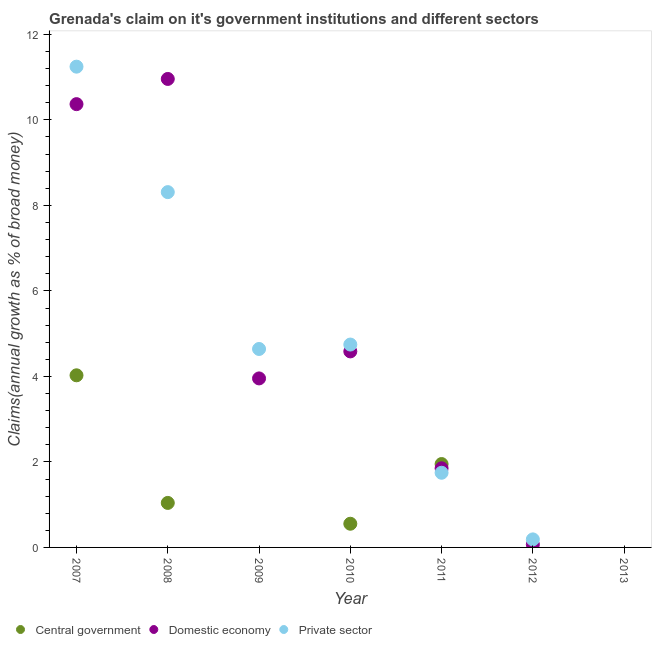What is the percentage of claim on the private sector in 2011?
Your answer should be very brief. 1.75. Across all years, what is the maximum percentage of claim on the private sector?
Give a very brief answer. 11.25. In which year was the percentage of claim on the private sector maximum?
Make the answer very short. 2007. What is the total percentage of claim on the private sector in the graph?
Provide a succinct answer. 30.88. What is the difference between the percentage of claim on the central government in 2010 and that in 2011?
Provide a short and direct response. -1.4. What is the difference between the percentage of claim on the central government in 2013 and the percentage of claim on the private sector in 2009?
Give a very brief answer. -4.64. What is the average percentage of claim on the central government per year?
Give a very brief answer. 1.08. In the year 2008, what is the difference between the percentage of claim on the domestic economy and percentage of claim on the private sector?
Offer a terse response. 2.65. In how many years, is the percentage of claim on the central government greater than 2 %?
Offer a terse response. 1. What is the ratio of the percentage of claim on the domestic economy in 2009 to that in 2011?
Provide a succinct answer. 2.14. What is the difference between the highest and the second highest percentage of claim on the private sector?
Give a very brief answer. 2.93. What is the difference between the highest and the lowest percentage of claim on the domestic economy?
Keep it short and to the point. 10.96. In how many years, is the percentage of claim on the private sector greater than the average percentage of claim on the private sector taken over all years?
Your response must be concise. 4. Is it the case that in every year, the sum of the percentage of claim on the central government and percentage of claim on the domestic economy is greater than the percentage of claim on the private sector?
Your response must be concise. No. Does the percentage of claim on the domestic economy monotonically increase over the years?
Offer a terse response. No. How many dotlines are there?
Give a very brief answer. 3. How many years are there in the graph?
Your answer should be very brief. 7. Are the values on the major ticks of Y-axis written in scientific E-notation?
Give a very brief answer. No. Does the graph contain any zero values?
Offer a terse response. Yes. Does the graph contain grids?
Give a very brief answer. No. How are the legend labels stacked?
Ensure brevity in your answer.  Horizontal. What is the title of the graph?
Give a very brief answer. Grenada's claim on it's government institutions and different sectors. What is the label or title of the Y-axis?
Keep it short and to the point. Claims(annual growth as % of broad money). What is the Claims(annual growth as % of broad money) of Central government in 2007?
Offer a terse response. 4.03. What is the Claims(annual growth as % of broad money) of Domestic economy in 2007?
Give a very brief answer. 10.37. What is the Claims(annual growth as % of broad money) of Private sector in 2007?
Keep it short and to the point. 11.25. What is the Claims(annual growth as % of broad money) of Central government in 2008?
Keep it short and to the point. 1.04. What is the Claims(annual growth as % of broad money) in Domestic economy in 2008?
Keep it short and to the point. 10.96. What is the Claims(annual growth as % of broad money) of Private sector in 2008?
Offer a terse response. 8.31. What is the Claims(annual growth as % of broad money) of Central government in 2009?
Make the answer very short. 0. What is the Claims(annual growth as % of broad money) of Domestic economy in 2009?
Give a very brief answer. 3.95. What is the Claims(annual growth as % of broad money) in Private sector in 2009?
Make the answer very short. 4.64. What is the Claims(annual growth as % of broad money) of Central government in 2010?
Ensure brevity in your answer.  0.55. What is the Claims(annual growth as % of broad money) in Domestic economy in 2010?
Provide a succinct answer. 4.58. What is the Claims(annual growth as % of broad money) of Private sector in 2010?
Offer a very short reply. 4.75. What is the Claims(annual growth as % of broad money) of Central government in 2011?
Offer a terse response. 1.95. What is the Claims(annual growth as % of broad money) of Domestic economy in 2011?
Offer a terse response. 1.85. What is the Claims(annual growth as % of broad money) of Private sector in 2011?
Make the answer very short. 1.75. What is the Claims(annual growth as % of broad money) of Domestic economy in 2012?
Your answer should be compact. 0.07. What is the Claims(annual growth as % of broad money) in Private sector in 2012?
Offer a very short reply. 0.19. What is the Claims(annual growth as % of broad money) in Domestic economy in 2013?
Keep it short and to the point. 0. Across all years, what is the maximum Claims(annual growth as % of broad money) in Central government?
Make the answer very short. 4.03. Across all years, what is the maximum Claims(annual growth as % of broad money) in Domestic economy?
Keep it short and to the point. 10.96. Across all years, what is the maximum Claims(annual growth as % of broad money) in Private sector?
Offer a terse response. 11.25. Across all years, what is the minimum Claims(annual growth as % of broad money) in Central government?
Your answer should be very brief. 0. Across all years, what is the minimum Claims(annual growth as % of broad money) in Domestic economy?
Offer a terse response. 0. What is the total Claims(annual growth as % of broad money) in Central government in the graph?
Your answer should be very brief. 7.57. What is the total Claims(annual growth as % of broad money) in Domestic economy in the graph?
Your response must be concise. 31.78. What is the total Claims(annual growth as % of broad money) of Private sector in the graph?
Provide a short and direct response. 30.88. What is the difference between the Claims(annual growth as % of broad money) in Central government in 2007 and that in 2008?
Offer a very short reply. 2.98. What is the difference between the Claims(annual growth as % of broad money) of Domestic economy in 2007 and that in 2008?
Ensure brevity in your answer.  -0.59. What is the difference between the Claims(annual growth as % of broad money) in Private sector in 2007 and that in 2008?
Your answer should be very brief. 2.93. What is the difference between the Claims(annual growth as % of broad money) in Domestic economy in 2007 and that in 2009?
Give a very brief answer. 6.42. What is the difference between the Claims(annual growth as % of broad money) in Private sector in 2007 and that in 2009?
Ensure brevity in your answer.  6.6. What is the difference between the Claims(annual growth as % of broad money) of Central government in 2007 and that in 2010?
Your response must be concise. 3.47. What is the difference between the Claims(annual growth as % of broad money) of Domestic economy in 2007 and that in 2010?
Your response must be concise. 5.78. What is the difference between the Claims(annual growth as % of broad money) in Central government in 2007 and that in 2011?
Provide a short and direct response. 2.08. What is the difference between the Claims(annual growth as % of broad money) in Domestic economy in 2007 and that in 2011?
Your response must be concise. 8.52. What is the difference between the Claims(annual growth as % of broad money) in Private sector in 2007 and that in 2011?
Offer a terse response. 9.5. What is the difference between the Claims(annual growth as % of broad money) of Domestic economy in 2007 and that in 2012?
Your response must be concise. 10.3. What is the difference between the Claims(annual growth as % of broad money) of Private sector in 2007 and that in 2012?
Ensure brevity in your answer.  11.06. What is the difference between the Claims(annual growth as % of broad money) of Domestic economy in 2008 and that in 2009?
Provide a succinct answer. 7. What is the difference between the Claims(annual growth as % of broad money) in Private sector in 2008 and that in 2009?
Keep it short and to the point. 3.67. What is the difference between the Claims(annual growth as % of broad money) of Central government in 2008 and that in 2010?
Make the answer very short. 0.49. What is the difference between the Claims(annual growth as % of broad money) in Domestic economy in 2008 and that in 2010?
Make the answer very short. 6.37. What is the difference between the Claims(annual growth as % of broad money) in Private sector in 2008 and that in 2010?
Your answer should be compact. 3.57. What is the difference between the Claims(annual growth as % of broad money) in Central government in 2008 and that in 2011?
Provide a succinct answer. -0.91. What is the difference between the Claims(annual growth as % of broad money) in Domestic economy in 2008 and that in 2011?
Offer a very short reply. 9.11. What is the difference between the Claims(annual growth as % of broad money) in Private sector in 2008 and that in 2011?
Your answer should be very brief. 6.56. What is the difference between the Claims(annual growth as % of broad money) in Domestic economy in 2008 and that in 2012?
Your response must be concise. 10.89. What is the difference between the Claims(annual growth as % of broad money) of Private sector in 2008 and that in 2012?
Keep it short and to the point. 8.12. What is the difference between the Claims(annual growth as % of broad money) of Domestic economy in 2009 and that in 2010?
Offer a terse response. -0.63. What is the difference between the Claims(annual growth as % of broad money) in Private sector in 2009 and that in 2010?
Your answer should be compact. -0.1. What is the difference between the Claims(annual growth as % of broad money) of Domestic economy in 2009 and that in 2011?
Provide a short and direct response. 2.1. What is the difference between the Claims(annual growth as % of broad money) in Private sector in 2009 and that in 2011?
Ensure brevity in your answer.  2.9. What is the difference between the Claims(annual growth as % of broad money) of Domestic economy in 2009 and that in 2012?
Ensure brevity in your answer.  3.88. What is the difference between the Claims(annual growth as % of broad money) of Private sector in 2009 and that in 2012?
Offer a terse response. 4.45. What is the difference between the Claims(annual growth as % of broad money) in Central government in 2010 and that in 2011?
Ensure brevity in your answer.  -1.4. What is the difference between the Claims(annual growth as % of broad money) in Domestic economy in 2010 and that in 2011?
Your answer should be compact. 2.73. What is the difference between the Claims(annual growth as % of broad money) in Private sector in 2010 and that in 2011?
Keep it short and to the point. 3. What is the difference between the Claims(annual growth as % of broad money) of Domestic economy in 2010 and that in 2012?
Provide a succinct answer. 4.52. What is the difference between the Claims(annual growth as % of broad money) of Private sector in 2010 and that in 2012?
Offer a terse response. 4.56. What is the difference between the Claims(annual growth as % of broad money) of Domestic economy in 2011 and that in 2012?
Provide a short and direct response. 1.78. What is the difference between the Claims(annual growth as % of broad money) in Private sector in 2011 and that in 2012?
Keep it short and to the point. 1.56. What is the difference between the Claims(annual growth as % of broad money) in Central government in 2007 and the Claims(annual growth as % of broad money) in Domestic economy in 2008?
Offer a very short reply. -6.93. What is the difference between the Claims(annual growth as % of broad money) of Central government in 2007 and the Claims(annual growth as % of broad money) of Private sector in 2008?
Keep it short and to the point. -4.28. What is the difference between the Claims(annual growth as % of broad money) of Domestic economy in 2007 and the Claims(annual growth as % of broad money) of Private sector in 2008?
Offer a very short reply. 2.06. What is the difference between the Claims(annual growth as % of broad money) of Central government in 2007 and the Claims(annual growth as % of broad money) of Domestic economy in 2009?
Your response must be concise. 0.07. What is the difference between the Claims(annual growth as % of broad money) of Central government in 2007 and the Claims(annual growth as % of broad money) of Private sector in 2009?
Provide a short and direct response. -0.62. What is the difference between the Claims(annual growth as % of broad money) of Domestic economy in 2007 and the Claims(annual growth as % of broad money) of Private sector in 2009?
Give a very brief answer. 5.73. What is the difference between the Claims(annual growth as % of broad money) of Central government in 2007 and the Claims(annual growth as % of broad money) of Domestic economy in 2010?
Offer a very short reply. -0.56. What is the difference between the Claims(annual growth as % of broad money) in Central government in 2007 and the Claims(annual growth as % of broad money) in Private sector in 2010?
Your response must be concise. -0.72. What is the difference between the Claims(annual growth as % of broad money) in Domestic economy in 2007 and the Claims(annual growth as % of broad money) in Private sector in 2010?
Give a very brief answer. 5.62. What is the difference between the Claims(annual growth as % of broad money) in Central government in 2007 and the Claims(annual growth as % of broad money) in Domestic economy in 2011?
Ensure brevity in your answer.  2.17. What is the difference between the Claims(annual growth as % of broad money) in Central government in 2007 and the Claims(annual growth as % of broad money) in Private sector in 2011?
Give a very brief answer. 2.28. What is the difference between the Claims(annual growth as % of broad money) in Domestic economy in 2007 and the Claims(annual growth as % of broad money) in Private sector in 2011?
Offer a very short reply. 8.62. What is the difference between the Claims(annual growth as % of broad money) in Central government in 2007 and the Claims(annual growth as % of broad money) in Domestic economy in 2012?
Make the answer very short. 3.96. What is the difference between the Claims(annual growth as % of broad money) of Central government in 2007 and the Claims(annual growth as % of broad money) of Private sector in 2012?
Provide a succinct answer. 3.84. What is the difference between the Claims(annual growth as % of broad money) in Domestic economy in 2007 and the Claims(annual growth as % of broad money) in Private sector in 2012?
Your response must be concise. 10.18. What is the difference between the Claims(annual growth as % of broad money) of Central government in 2008 and the Claims(annual growth as % of broad money) of Domestic economy in 2009?
Provide a short and direct response. -2.91. What is the difference between the Claims(annual growth as % of broad money) of Central government in 2008 and the Claims(annual growth as % of broad money) of Private sector in 2009?
Your response must be concise. -3.6. What is the difference between the Claims(annual growth as % of broad money) in Domestic economy in 2008 and the Claims(annual growth as % of broad money) in Private sector in 2009?
Offer a very short reply. 6.32. What is the difference between the Claims(annual growth as % of broad money) of Central government in 2008 and the Claims(annual growth as % of broad money) of Domestic economy in 2010?
Offer a terse response. -3.54. What is the difference between the Claims(annual growth as % of broad money) of Central government in 2008 and the Claims(annual growth as % of broad money) of Private sector in 2010?
Provide a succinct answer. -3.7. What is the difference between the Claims(annual growth as % of broad money) of Domestic economy in 2008 and the Claims(annual growth as % of broad money) of Private sector in 2010?
Keep it short and to the point. 6.21. What is the difference between the Claims(annual growth as % of broad money) of Central government in 2008 and the Claims(annual growth as % of broad money) of Domestic economy in 2011?
Your answer should be very brief. -0.81. What is the difference between the Claims(annual growth as % of broad money) of Central government in 2008 and the Claims(annual growth as % of broad money) of Private sector in 2011?
Your answer should be very brief. -0.71. What is the difference between the Claims(annual growth as % of broad money) in Domestic economy in 2008 and the Claims(annual growth as % of broad money) in Private sector in 2011?
Provide a short and direct response. 9.21. What is the difference between the Claims(annual growth as % of broad money) of Central government in 2008 and the Claims(annual growth as % of broad money) of Domestic economy in 2012?
Your answer should be very brief. 0.97. What is the difference between the Claims(annual growth as % of broad money) in Central government in 2008 and the Claims(annual growth as % of broad money) in Private sector in 2012?
Your answer should be very brief. 0.85. What is the difference between the Claims(annual growth as % of broad money) in Domestic economy in 2008 and the Claims(annual growth as % of broad money) in Private sector in 2012?
Provide a short and direct response. 10.77. What is the difference between the Claims(annual growth as % of broad money) of Domestic economy in 2009 and the Claims(annual growth as % of broad money) of Private sector in 2010?
Provide a short and direct response. -0.79. What is the difference between the Claims(annual growth as % of broad money) of Domestic economy in 2009 and the Claims(annual growth as % of broad money) of Private sector in 2011?
Your answer should be very brief. 2.21. What is the difference between the Claims(annual growth as % of broad money) in Domestic economy in 2009 and the Claims(annual growth as % of broad money) in Private sector in 2012?
Ensure brevity in your answer.  3.76. What is the difference between the Claims(annual growth as % of broad money) of Central government in 2010 and the Claims(annual growth as % of broad money) of Domestic economy in 2011?
Ensure brevity in your answer.  -1.3. What is the difference between the Claims(annual growth as % of broad money) of Central government in 2010 and the Claims(annual growth as % of broad money) of Private sector in 2011?
Offer a terse response. -1.19. What is the difference between the Claims(annual growth as % of broad money) in Domestic economy in 2010 and the Claims(annual growth as % of broad money) in Private sector in 2011?
Provide a succinct answer. 2.84. What is the difference between the Claims(annual growth as % of broad money) in Central government in 2010 and the Claims(annual growth as % of broad money) in Domestic economy in 2012?
Your response must be concise. 0.48. What is the difference between the Claims(annual growth as % of broad money) of Central government in 2010 and the Claims(annual growth as % of broad money) of Private sector in 2012?
Keep it short and to the point. 0.37. What is the difference between the Claims(annual growth as % of broad money) of Domestic economy in 2010 and the Claims(annual growth as % of broad money) of Private sector in 2012?
Your response must be concise. 4.4. What is the difference between the Claims(annual growth as % of broad money) of Central government in 2011 and the Claims(annual growth as % of broad money) of Domestic economy in 2012?
Keep it short and to the point. 1.88. What is the difference between the Claims(annual growth as % of broad money) in Central government in 2011 and the Claims(annual growth as % of broad money) in Private sector in 2012?
Keep it short and to the point. 1.76. What is the difference between the Claims(annual growth as % of broad money) in Domestic economy in 2011 and the Claims(annual growth as % of broad money) in Private sector in 2012?
Your answer should be very brief. 1.66. What is the average Claims(annual growth as % of broad money) of Central government per year?
Provide a succinct answer. 1.08. What is the average Claims(annual growth as % of broad money) in Domestic economy per year?
Make the answer very short. 4.54. What is the average Claims(annual growth as % of broad money) of Private sector per year?
Your answer should be compact. 4.41. In the year 2007, what is the difference between the Claims(annual growth as % of broad money) of Central government and Claims(annual growth as % of broad money) of Domestic economy?
Give a very brief answer. -6.34. In the year 2007, what is the difference between the Claims(annual growth as % of broad money) of Central government and Claims(annual growth as % of broad money) of Private sector?
Ensure brevity in your answer.  -7.22. In the year 2007, what is the difference between the Claims(annual growth as % of broad money) of Domestic economy and Claims(annual growth as % of broad money) of Private sector?
Your answer should be compact. -0.88. In the year 2008, what is the difference between the Claims(annual growth as % of broad money) of Central government and Claims(annual growth as % of broad money) of Domestic economy?
Your answer should be very brief. -9.92. In the year 2008, what is the difference between the Claims(annual growth as % of broad money) in Central government and Claims(annual growth as % of broad money) in Private sector?
Ensure brevity in your answer.  -7.27. In the year 2008, what is the difference between the Claims(annual growth as % of broad money) in Domestic economy and Claims(annual growth as % of broad money) in Private sector?
Your answer should be compact. 2.65. In the year 2009, what is the difference between the Claims(annual growth as % of broad money) of Domestic economy and Claims(annual growth as % of broad money) of Private sector?
Make the answer very short. -0.69. In the year 2010, what is the difference between the Claims(annual growth as % of broad money) of Central government and Claims(annual growth as % of broad money) of Domestic economy?
Ensure brevity in your answer.  -4.03. In the year 2010, what is the difference between the Claims(annual growth as % of broad money) of Central government and Claims(annual growth as % of broad money) of Private sector?
Provide a succinct answer. -4.19. In the year 2010, what is the difference between the Claims(annual growth as % of broad money) in Domestic economy and Claims(annual growth as % of broad money) in Private sector?
Provide a succinct answer. -0.16. In the year 2011, what is the difference between the Claims(annual growth as % of broad money) in Central government and Claims(annual growth as % of broad money) in Domestic economy?
Offer a very short reply. 0.1. In the year 2011, what is the difference between the Claims(annual growth as % of broad money) in Central government and Claims(annual growth as % of broad money) in Private sector?
Your answer should be compact. 0.2. In the year 2011, what is the difference between the Claims(annual growth as % of broad money) in Domestic economy and Claims(annual growth as % of broad money) in Private sector?
Ensure brevity in your answer.  0.1. In the year 2012, what is the difference between the Claims(annual growth as % of broad money) in Domestic economy and Claims(annual growth as % of broad money) in Private sector?
Your response must be concise. -0.12. What is the ratio of the Claims(annual growth as % of broad money) in Central government in 2007 to that in 2008?
Your answer should be very brief. 3.87. What is the ratio of the Claims(annual growth as % of broad money) in Domestic economy in 2007 to that in 2008?
Make the answer very short. 0.95. What is the ratio of the Claims(annual growth as % of broad money) of Private sector in 2007 to that in 2008?
Provide a succinct answer. 1.35. What is the ratio of the Claims(annual growth as % of broad money) in Domestic economy in 2007 to that in 2009?
Offer a terse response. 2.62. What is the ratio of the Claims(annual growth as % of broad money) in Private sector in 2007 to that in 2009?
Keep it short and to the point. 2.42. What is the ratio of the Claims(annual growth as % of broad money) of Central government in 2007 to that in 2010?
Give a very brief answer. 7.27. What is the ratio of the Claims(annual growth as % of broad money) of Domestic economy in 2007 to that in 2010?
Your response must be concise. 2.26. What is the ratio of the Claims(annual growth as % of broad money) in Private sector in 2007 to that in 2010?
Your answer should be compact. 2.37. What is the ratio of the Claims(annual growth as % of broad money) in Central government in 2007 to that in 2011?
Provide a succinct answer. 2.06. What is the ratio of the Claims(annual growth as % of broad money) of Domestic economy in 2007 to that in 2011?
Your answer should be very brief. 5.6. What is the ratio of the Claims(annual growth as % of broad money) of Private sector in 2007 to that in 2011?
Offer a terse response. 6.44. What is the ratio of the Claims(annual growth as % of broad money) of Domestic economy in 2007 to that in 2012?
Keep it short and to the point. 149.95. What is the ratio of the Claims(annual growth as % of broad money) of Private sector in 2007 to that in 2012?
Keep it short and to the point. 59.76. What is the ratio of the Claims(annual growth as % of broad money) in Domestic economy in 2008 to that in 2009?
Provide a succinct answer. 2.77. What is the ratio of the Claims(annual growth as % of broad money) of Private sector in 2008 to that in 2009?
Ensure brevity in your answer.  1.79. What is the ratio of the Claims(annual growth as % of broad money) of Central government in 2008 to that in 2010?
Provide a short and direct response. 1.88. What is the ratio of the Claims(annual growth as % of broad money) of Domestic economy in 2008 to that in 2010?
Your answer should be very brief. 2.39. What is the ratio of the Claims(annual growth as % of broad money) of Private sector in 2008 to that in 2010?
Give a very brief answer. 1.75. What is the ratio of the Claims(annual growth as % of broad money) of Central government in 2008 to that in 2011?
Your answer should be compact. 0.53. What is the ratio of the Claims(annual growth as % of broad money) of Domestic economy in 2008 to that in 2011?
Offer a terse response. 5.92. What is the ratio of the Claims(annual growth as % of broad money) in Private sector in 2008 to that in 2011?
Your answer should be very brief. 4.76. What is the ratio of the Claims(annual growth as % of broad money) of Domestic economy in 2008 to that in 2012?
Ensure brevity in your answer.  158.48. What is the ratio of the Claims(annual growth as % of broad money) of Private sector in 2008 to that in 2012?
Provide a succinct answer. 44.16. What is the ratio of the Claims(annual growth as % of broad money) in Domestic economy in 2009 to that in 2010?
Offer a very short reply. 0.86. What is the ratio of the Claims(annual growth as % of broad money) in Private sector in 2009 to that in 2010?
Your answer should be compact. 0.98. What is the ratio of the Claims(annual growth as % of broad money) in Domestic economy in 2009 to that in 2011?
Provide a succinct answer. 2.14. What is the ratio of the Claims(annual growth as % of broad money) of Private sector in 2009 to that in 2011?
Make the answer very short. 2.66. What is the ratio of the Claims(annual growth as % of broad money) in Domestic economy in 2009 to that in 2012?
Offer a very short reply. 57.17. What is the ratio of the Claims(annual growth as % of broad money) in Private sector in 2009 to that in 2012?
Offer a terse response. 24.67. What is the ratio of the Claims(annual growth as % of broad money) in Central government in 2010 to that in 2011?
Provide a succinct answer. 0.28. What is the ratio of the Claims(annual growth as % of broad money) in Domestic economy in 2010 to that in 2011?
Make the answer very short. 2.48. What is the ratio of the Claims(annual growth as % of broad money) of Private sector in 2010 to that in 2011?
Give a very brief answer. 2.72. What is the ratio of the Claims(annual growth as % of broad money) in Domestic economy in 2010 to that in 2012?
Ensure brevity in your answer.  66.31. What is the ratio of the Claims(annual growth as % of broad money) in Private sector in 2010 to that in 2012?
Your response must be concise. 25.22. What is the ratio of the Claims(annual growth as % of broad money) in Domestic economy in 2011 to that in 2012?
Your answer should be compact. 26.77. What is the ratio of the Claims(annual growth as % of broad money) in Private sector in 2011 to that in 2012?
Your answer should be compact. 9.28. What is the difference between the highest and the second highest Claims(annual growth as % of broad money) of Central government?
Your answer should be very brief. 2.08. What is the difference between the highest and the second highest Claims(annual growth as % of broad money) of Domestic economy?
Offer a very short reply. 0.59. What is the difference between the highest and the second highest Claims(annual growth as % of broad money) of Private sector?
Provide a succinct answer. 2.93. What is the difference between the highest and the lowest Claims(annual growth as % of broad money) in Central government?
Offer a very short reply. 4.03. What is the difference between the highest and the lowest Claims(annual growth as % of broad money) of Domestic economy?
Make the answer very short. 10.96. What is the difference between the highest and the lowest Claims(annual growth as % of broad money) in Private sector?
Ensure brevity in your answer.  11.25. 